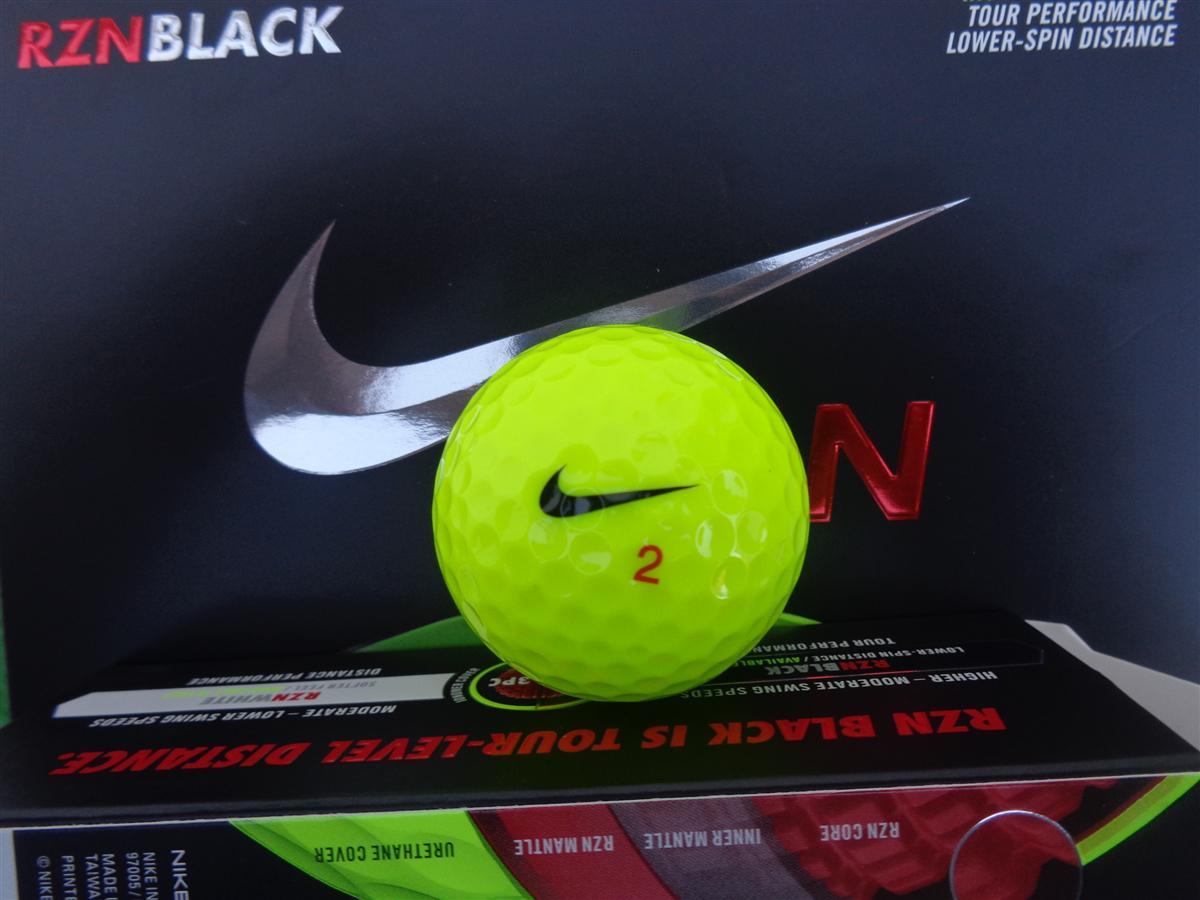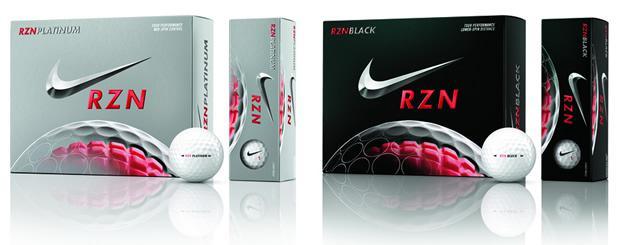The first image is the image on the left, the second image is the image on the right. Assess this claim about the two images: "There are exactly three golf balls that aren't in a box.". Correct or not? Answer yes or no. Yes. The first image is the image on the left, the second image is the image on the right. Given the left and right images, does the statement "In at least one image there are two black boxes that have silver and red on them." hold true? Answer yes or no. Yes. 